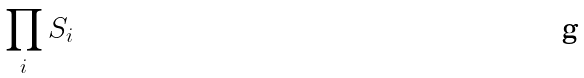Convert formula to latex. <formula><loc_0><loc_0><loc_500><loc_500>\prod _ { i } S _ { i }</formula> 